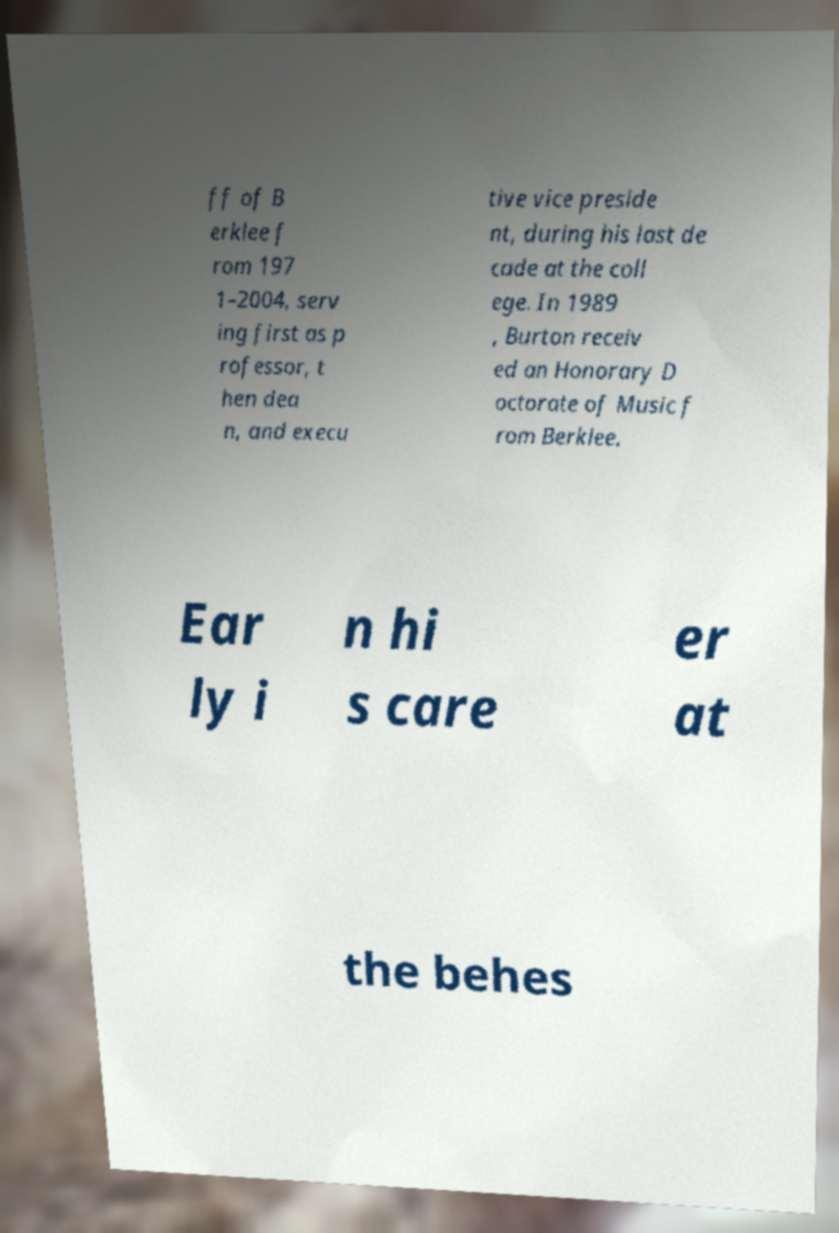Please read and relay the text visible in this image. What does it say? ff of B erklee f rom 197 1–2004, serv ing first as p rofessor, t hen dea n, and execu tive vice preside nt, during his last de cade at the coll ege. In 1989 , Burton receiv ed an Honorary D octorate of Music f rom Berklee. Ear ly i n hi s care er at the behes 